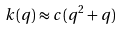Convert formula to latex. <formula><loc_0><loc_0><loc_500><loc_500>k ( q ) \approx c ( q ^ { 2 } + q )</formula> 